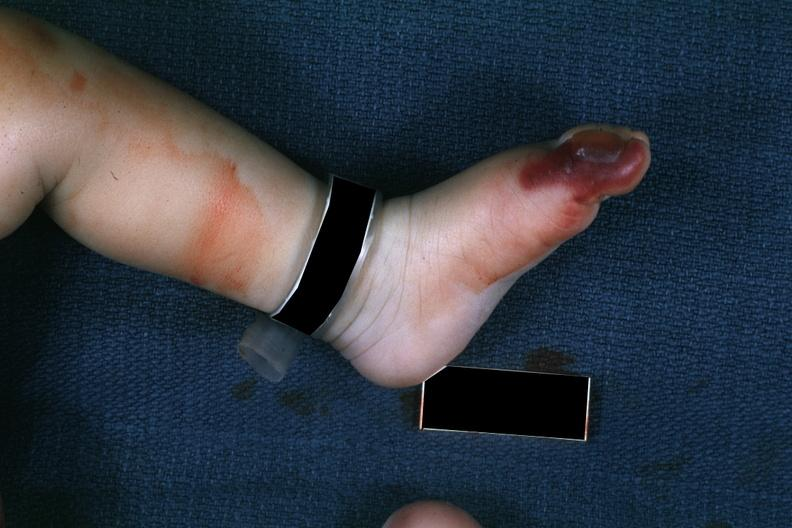what does this image show?
Answer the question using a single word or phrase. 1 month old child with congenital aortic stenosis 